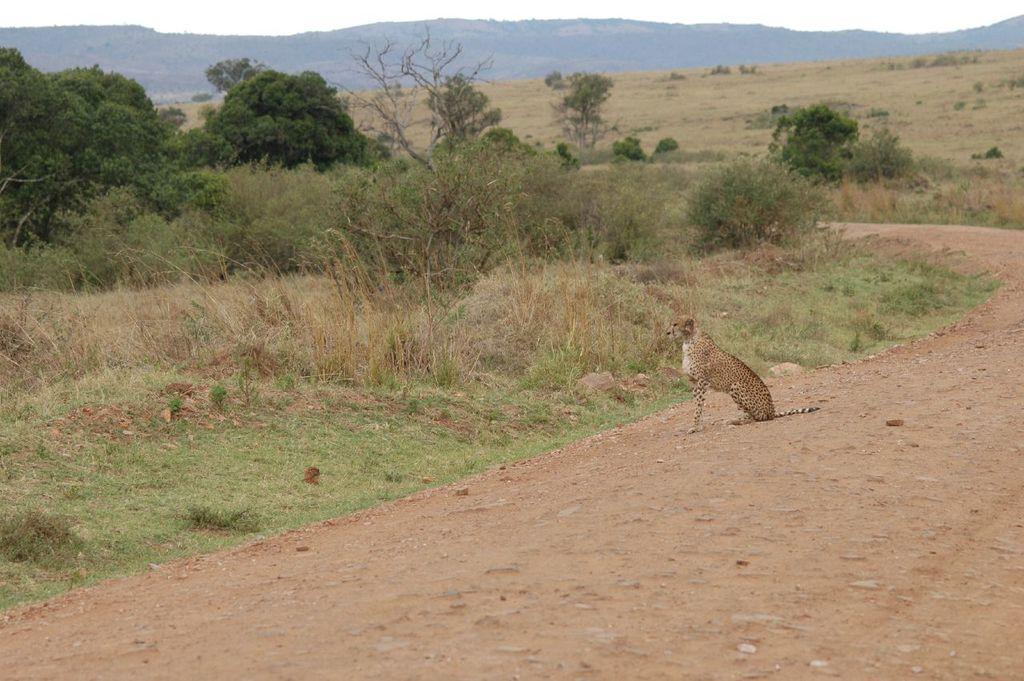Could you give a brief overview of what you see in this image? In the picture we can see a muddy path on it, we can see a cheetah sitting and besides, we can see a grass surface, plants, trees and hills and sky. 